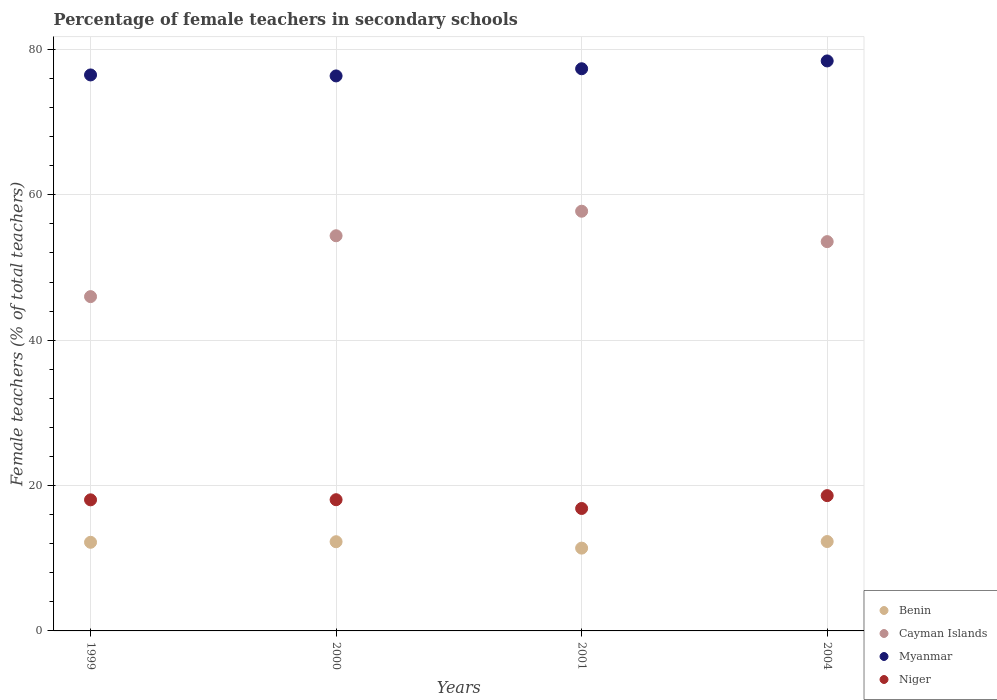How many different coloured dotlines are there?
Ensure brevity in your answer.  4. What is the percentage of female teachers in Cayman Islands in 1999?
Make the answer very short. 45.99. Across all years, what is the maximum percentage of female teachers in Benin?
Give a very brief answer. 12.3. Across all years, what is the minimum percentage of female teachers in Cayman Islands?
Provide a succinct answer. 45.99. In which year was the percentage of female teachers in Cayman Islands maximum?
Your answer should be compact. 2001. What is the total percentage of female teachers in Niger in the graph?
Offer a terse response. 71.54. What is the difference between the percentage of female teachers in Myanmar in 1999 and that in 2001?
Give a very brief answer. -0.85. What is the difference between the percentage of female teachers in Cayman Islands in 2001 and the percentage of female teachers in Niger in 2000?
Your answer should be compact. 39.69. What is the average percentage of female teachers in Cayman Islands per year?
Offer a terse response. 52.91. In the year 2004, what is the difference between the percentage of female teachers in Niger and percentage of female teachers in Myanmar?
Provide a short and direct response. -59.8. In how many years, is the percentage of female teachers in Benin greater than 24 %?
Make the answer very short. 0. What is the ratio of the percentage of female teachers in Cayman Islands in 1999 to that in 2000?
Keep it short and to the point. 0.85. Is the difference between the percentage of female teachers in Niger in 1999 and 2001 greater than the difference between the percentage of female teachers in Myanmar in 1999 and 2001?
Your answer should be compact. Yes. What is the difference between the highest and the second highest percentage of female teachers in Cayman Islands?
Give a very brief answer. 3.38. What is the difference between the highest and the lowest percentage of female teachers in Myanmar?
Provide a short and direct response. 2.06. In how many years, is the percentage of female teachers in Myanmar greater than the average percentage of female teachers in Myanmar taken over all years?
Offer a terse response. 2. Is it the case that in every year, the sum of the percentage of female teachers in Myanmar and percentage of female teachers in Benin  is greater than the sum of percentage of female teachers in Niger and percentage of female teachers in Cayman Islands?
Ensure brevity in your answer.  No. How many dotlines are there?
Ensure brevity in your answer.  4. How many years are there in the graph?
Ensure brevity in your answer.  4. Does the graph contain any zero values?
Your response must be concise. No. Does the graph contain grids?
Your answer should be compact. Yes. Where does the legend appear in the graph?
Your answer should be very brief. Bottom right. What is the title of the graph?
Your response must be concise. Percentage of female teachers in secondary schools. What is the label or title of the Y-axis?
Your response must be concise. Female teachers (% of total teachers). What is the Female teachers (% of total teachers) of Benin in 1999?
Provide a succinct answer. 12.19. What is the Female teachers (% of total teachers) in Cayman Islands in 1999?
Offer a very short reply. 45.99. What is the Female teachers (% of total teachers) of Myanmar in 1999?
Give a very brief answer. 76.49. What is the Female teachers (% of total teachers) in Niger in 1999?
Make the answer very short. 18.03. What is the Female teachers (% of total teachers) of Benin in 2000?
Make the answer very short. 12.27. What is the Female teachers (% of total teachers) in Cayman Islands in 2000?
Make the answer very short. 54.37. What is the Female teachers (% of total teachers) in Myanmar in 2000?
Ensure brevity in your answer.  76.35. What is the Female teachers (% of total teachers) of Niger in 2000?
Provide a short and direct response. 18.05. What is the Female teachers (% of total teachers) of Benin in 2001?
Ensure brevity in your answer.  11.39. What is the Female teachers (% of total teachers) of Cayman Islands in 2001?
Ensure brevity in your answer.  57.74. What is the Female teachers (% of total teachers) in Myanmar in 2001?
Your response must be concise. 77.34. What is the Female teachers (% of total teachers) in Niger in 2001?
Ensure brevity in your answer.  16.84. What is the Female teachers (% of total teachers) in Benin in 2004?
Your answer should be compact. 12.3. What is the Female teachers (% of total teachers) of Cayman Islands in 2004?
Provide a succinct answer. 53.56. What is the Female teachers (% of total teachers) in Myanmar in 2004?
Make the answer very short. 78.42. What is the Female teachers (% of total teachers) in Niger in 2004?
Keep it short and to the point. 18.61. Across all years, what is the maximum Female teachers (% of total teachers) of Benin?
Your response must be concise. 12.3. Across all years, what is the maximum Female teachers (% of total teachers) in Cayman Islands?
Provide a succinct answer. 57.74. Across all years, what is the maximum Female teachers (% of total teachers) of Myanmar?
Offer a very short reply. 78.42. Across all years, what is the maximum Female teachers (% of total teachers) of Niger?
Your answer should be very brief. 18.61. Across all years, what is the minimum Female teachers (% of total teachers) in Benin?
Give a very brief answer. 11.39. Across all years, what is the minimum Female teachers (% of total teachers) of Cayman Islands?
Offer a terse response. 45.99. Across all years, what is the minimum Female teachers (% of total teachers) of Myanmar?
Provide a short and direct response. 76.35. Across all years, what is the minimum Female teachers (% of total teachers) of Niger?
Your answer should be compact. 16.84. What is the total Female teachers (% of total teachers) of Benin in the graph?
Ensure brevity in your answer.  48.15. What is the total Female teachers (% of total teachers) in Cayman Islands in the graph?
Your answer should be very brief. 211.65. What is the total Female teachers (% of total teachers) of Myanmar in the graph?
Offer a very short reply. 308.6. What is the total Female teachers (% of total teachers) in Niger in the graph?
Keep it short and to the point. 71.54. What is the difference between the Female teachers (% of total teachers) in Benin in 1999 and that in 2000?
Your answer should be compact. -0.08. What is the difference between the Female teachers (% of total teachers) of Cayman Islands in 1999 and that in 2000?
Give a very brief answer. -8.37. What is the difference between the Female teachers (% of total teachers) in Myanmar in 1999 and that in 2000?
Make the answer very short. 0.14. What is the difference between the Female teachers (% of total teachers) of Niger in 1999 and that in 2000?
Provide a short and direct response. -0.02. What is the difference between the Female teachers (% of total teachers) of Benin in 1999 and that in 2001?
Keep it short and to the point. 0.8. What is the difference between the Female teachers (% of total teachers) of Cayman Islands in 1999 and that in 2001?
Your response must be concise. -11.75. What is the difference between the Female teachers (% of total teachers) in Myanmar in 1999 and that in 2001?
Your response must be concise. -0.85. What is the difference between the Female teachers (% of total teachers) of Niger in 1999 and that in 2001?
Ensure brevity in your answer.  1.19. What is the difference between the Female teachers (% of total teachers) of Benin in 1999 and that in 2004?
Provide a short and direct response. -0.1. What is the difference between the Female teachers (% of total teachers) of Cayman Islands in 1999 and that in 2004?
Make the answer very short. -7.56. What is the difference between the Female teachers (% of total teachers) of Myanmar in 1999 and that in 2004?
Provide a succinct answer. -1.93. What is the difference between the Female teachers (% of total teachers) of Niger in 1999 and that in 2004?
Offer a terse response. -0.58. What is the difference between the Female teachers (% of total teachers) in Benin in 2000 and that in 2001?
Your answer should be very brief. 0.88. What is the difference between the Female teachers (% of total teachers) in Cayman Islands in 2000 and that in 2001?
Ensure brevity in your answer.  -3.38. What is the difference between the Female teachers (% of total teachers) in Myanmar in 2000 and that in 2001?
Your answer should be very brief. -0.99. What is the difference between the Female teachers (% of total teachers) of Niger in 2000 and that in 2001?
Keep it short and to the point. 1.21. What is the difference between the Female teachers (% of total teachers) in Benin in 2000 and that in 2004?
Your answer should be very brief. -0.03. What is the difference between the Female teachers (% of total teachers) of Cayman Islands in 2000 and that in 2004?
Provide a short and direct response. 0.81. What is the difference between the Female teachers (% of total teachers) of Myanmar in 2000 and that in 2004?
Provide a succinct answer. -2.06. What is the difference between the Female teachers (% of total teachers) in Niger in 2000 and that in 2004?
Make the answer very short. -0.56. What is the difference between the Female teachers (% of total teachers) of Benin in 2001 and that in 2004?
Give a very brief answer. -0.91. What is the difference between the Female teachers (% of total teachers) in Cayman Islands in 2001 and that in 2004?
Your response must be concise. 4.18. What is the difference between the Female teachers (% of total teachers) in Myanmar in 2001 and that in 2004?
Your response must be concise. -1.08. What is the difference between the Female teachers (% of total teachers) of Niger in 2001 and that in 2004?
Offer a terse response. -1.77. What is the difference between the Female teachers (% of total teachers) in Benin in 1999 and the Female teachers (% of total teachers) in Cayman Islands in 2000?
Your answer should be very brief. -42.17. What is the difference between the Female teachers (% of total teachers) of Benin in 1999 and the Female teachers (% of total teachers) of Myanmar in 2000?
Keep it short and to the point. -64.16. What is the difference between the Female teachers (% of total teachers) in Benin in 1999 and the Female teachers (% of total teachers) in Niger in 2000?
Your answer should be very brief. -5.86. What is the difference between the Female teachers (% of total teachers) of Cayman Islands in 1999 and the Female teachers (% of total teachers) of Myanmar in 2000?
Make the answer very short. -30.36. What is the difference between the Female teachers (% of total teachers) in Cayman Islands in 1999 and the Female teachers (% of total teachers) in Niger in 2000?
Make the answer very short. 27.94. What is the difference between the Female teachers (% of total teachers) in Myanmar in 1999 and the Female teachers (% of total teachers) in Niger in 2000?
Your answer should be very brief. 58.44. What is the difference between the Female teachers (% of total teachers) of Benin in 1999 and the Female teachers (% of total teachers) of Cayman Islands in 2001?
Offer a very short reply. -45.55. What is the difference between the Female teachers (% of total teachers) of Benin in 1999 and the Female teachers (% of total teachers) of Myanmar in 2001?
Provide a succinct answer. -65.15. What is the difference between the Female teachers (% of total teachers) of Benin in 1999 and the Female teachers (% of total teachers) of Niger in 2001?
Offer a very short reply. -4.65. What is the difference between the Female teachers (% of total teachers) of Cayman Islands in 1999 and the Female teachers (% of total teachers) of Myanmar in 2001?
Keep it short and to the point. -31.35. What is the difference between the Female teachers (% of total teachers) of Cayman Islands in 1999 and the Female teachers (% of total teachers) of Niger in 2001?
Keep it short and to the point. 29.15. What is the difference between the Female teachers (% of total teachers) of Myanmar in 1999 and the Female teachers (% of total teachers) of Niger in 2001?
Keep it short and to the point. 59.65. What is the difference between the Female teachers (% of total teachers) in Benin in 1999 and the Female teachers (% of total teachers) in Cayman Islands in 2004?
Make the answer very short. -41.36. What is the difference between the Female teachers (% of total teachers) of Benin in 1999 and the Female teachers (% of total teachers) of Myanmar in 2004?
Make the answer very short. -66.22. What is the difference between the Female teachers (% of total teachers) of Benin in 1999 and the Female teachers (% of total teachers) of Niger in 2004?
Make the answer very short. -6.42. What is the difference between the Female teachers (% of total teachers) of Cayman Islands in 1999 and the Female teachers (% of total teachers) of Myanmar in 2004?
Make the answer very short. -32.43. What is the difference between the Female teachers (% of total teachers) of Cayman Islands in 1999 and the Female teachers (% of total teachers) of Niger in 2004?
Make the answer very short. 27.38. What is the difference between the Female teachers (% of total teachers) in Myanmar in 1999 and the Female teachers (% of total teachers) in Niger in 2004?
Make the answer very short. 57.88. What is the difference between the Female teachers (% of total teachers) in Benin in 2000 and the Female teachers (% of total teachers) in Cayman Islands in 2001?
Provide a short and direct response. -45.47. What is the difference between the Female teachers (% of total teachers) of Benin in 2000 and the Female teachers (% of total teachers) of Myanmar in 2001?
Offer a terse response. -65.07. What is the difference between the Female teachers (% of total teachers) of Benin in 2000 and the Female teachers (% of total teachers) of Niger in 2001?
Give a very brief answer. -4.57. What is the difference between the Female teachers (% of total teachers) of Cayman Islands in 2000 and the Female teachers (% of total teachers) of Myanmar in 2001?
Ensure brevity in your answer.  -22.98. What is the difference between the Female teachers (% of total teachers) in Cayman Islands in 2000 and the Female teachers (% of total teachers) in Niger in 2001?
Your response must be concise. 37.52. What is the difference between the Female teachers (% of total teachers) of Myanmar in 2000 and the Female teachers (% of total teachers) of Niger in 2001?
Ensure brevity in your answer.  59.51. What is the difference between the Female teachers (% of total teachers) in Benin in 2000 and the Female teachers (% of total teachers) in Cayman Islands in 2004?
Offer a terse response. -41.28. What is the difference between the Female teachers (% of total teachers) in Benin in 2000 and the Female teachers (% of total teachers) in Myanmar in 2004?
Your answer should be compact. -66.14. What is the difference between the Female teachers (% of total teachers) of Benin in 2000 and the Female teachers (% of total teachers) of Niger in 2004?
Provide a succinct answer. -6.34. What is the difference between the Female teachers (% of total teachers) of Cayman Islands in 2000 and the Female teachers (% of total teachers) of Myanmar in 2004?
Your answer should be compact. -24.05. What is the difference between the Female teachers (% of total teachers) in Cayman Islands in 2000 and the Female teachers (% of total teachers) in Niger in 2004?
Keep it short and to the point. 35.75. What is the difference between the Female teachers (% of total teachers) in Myanmar in 2000 and the Female teachers (% of total teachers) in Niger in 2004?
Your answer should be very brief. 57.74. What is the difference between the Female teachers (% of total teachers) of Benin in 2001 and the Female teachers (% of total teachers) of Cayman Islands in 2004?
Give a very brief answer. -42.17. What is the difference between the Female teachers (% of total teachers) of Benin in 2001 and the Female teachers (% of total teachers) of Myanmar in 2004?
Give a very brief answer. -67.03. What is the difference between the Female teachers (% of total teachers) in Benin in 2001 and the Female teachers (% of total teachers) in Niger in 2004?
Make the answer very short. -7.22. What is the difference between the Female teachers (% of total teachers) in Cayman Islands in 2001 and the Female teachers (% of total teachers) in Myanmar in 2004?
Keep it short and to the point. -20.68. What is the difference between the Female teachers (% of total teachers) in Cayman Islands in 2001 and the Female teachers (% of total teachers) in Niger in 2004?
Your answer should be very brief. 39.13. What is the difference between the Female teachers (% of total teachers) in Myanmar in 2001 and the Female teachers (% of total teachers) in Niger in 2004?
Make the answer very short. 58.73. What is the average Female teachers (% of total teachers) in Benin per year?
Offer a terse response. 12.04. What is the average Female teachers (% of total teachers) in Cayman Islands per year?
Ensure brevity in your answer.  52.91. What is the average Female teachers (% of total teachers) of Myanmar per year?
Your response must be concise. 77.15. What is the average Female teachers (% of total teachers) in Niger per year?
Your answer should be compact. 17.89. In the year 1999, what is the difference between the Female teachers (% of total teachers) in Benin and Female teachers (% of total teachers) in Cayman Islands?
Your response must be concise. -33.8. In the year 1999, what is the difference between the Female teachers (% of total teachers) of Benin and Female teachers (% of total teachers) of Myanmar?
Provide a short and direct response. -64.3. In the year 1999, what is the difference between the Female teachers (% of total teachers) in Benin and Female teachers (% of total teachers) in Niger?
Your answer should be very brief. -5.84. In the year 1999, what is the difference between the Female teachers (% of total teachers) of Cayman Islands and Female teachers (% of total teachers) of Myanmar?
Give a very brief answer. -30.5. In the year 1999, what is the difference between the Female teachers (% of total teachers) in Cayman Islands and Female teachers (% of total teachers) in Niger?
Provide a short and direct response. 27.96. In the year 1999, what is the difference between the Female teachers (% of total teachers) of Myanmar and Female teachers (% of total teachers) of Niger?
Give a very brief answer. 58.46. In the year 2000, what is the difference between the Female teachers (% of total teachers) of Benin and Female teachers (% of total teachers) of Cayman Islands?
Your answer should be compact. -42.09. In the year 2000, what is the difference between the Female teachers (% of total teachers) of Benin and Female teachers (% of total teachers) of Myanmar?
Your answer should be compact. -64.08. In the year 2000, what is the difference between the Female teachers (% of total teachers) in Benin and Female teachers (% of total teachers) in Niger?
Offer a very short reply. -5.78. In the year 2000, what is the difference between the Female teachers (% of total teachers) of Cayman Islands and Female teachers (% of total teachers) of Myanmar?
Provide a short and direct response. -21.99. In the year 2000, what is the difference between the Female teachers (% of total teachers) of Cayman Islands and Female teachers (% of total teachers) of Niger?
Keep it short and to the point. 36.31. In the year 2000, what is the difference between the Female teachers (% of total teachers) of Myanmar and Female teachers (% of total teachers) of Niger?
Offer a very short reply. 58.3. In the year 2001, what is the difference between the Female teachers (% of total teachers) of Benin and Female teachers (% of total teachers) of Cayman Islands?
Your answer should be very brief. -46.35. In the year 2001, what is the difference between the Female teachers (% of total teachers) in Benin and Female teachers (% of total teachers) in Myanmar?
Ensure brevity in your answer.  -65.95. In the year 2001, what is the difference between the Female teachers (% of total teachers) in Benin and Female teachers (% of total teachers) in Niger?
Provide a short and direct response. -5.45. In the year 2001, what is the difference between the Female teachers (% of total teachers) in Cayman Islands and Female teachers (% of total teachers) in Myanmar?
Provide a short and direct response. -19.6. In the year 2001, what is the difference between the Female teachers (% of total teachers) of Cayman Islands and Female teachers (% of total teachers) of Niger?
Your answer should be compact. 40.9. In the year 2001, what is the difference between the Female teachers (% of total teachers) of Myanmar and Female teachers (% of total teachers) of Niger?
Provide a short and direct response. 60.5. In the year 2004, what is the difference between the Female teachers (% of total teachers) of Benin and Female teachers (% of total teachers) of Cayman Islands?
Keep it short and to the point. -41.26. In the year 2004, what is the difference between the Female teachers (% of total teachers) in Benin and Female teachers (% of total teachers) in Myanmar?
Provide a short and direct response. -66.12. In the year 2004, what is the difference between the Female teachers (% of total teachers) of Benin and Female teachers (% of total teachers) of Niger?
Offer a very short reply. -6.32. In the year 2004, what is the difference between the Female teachers (% of total teachers) of Cayman Islands and Female teachers (% of total teachers) of Myanmar?
Ensure brevity in your answer.  -24.86. In the year 2004, what is the difference between the Female teachers (% of total teachers) of Cayman Islands and Female teachers (% of total teachers) of Niger?
Your answer should be very brief. 34.94. In the year 2004, what is the difference between the Female teachers (% of total teachers) in Myanmar and Female teachers (% of total teachers) in Niger?
Your answer should be very brief. 59.8. What is the ratio of the Female teachers (% of total teachers) in Benin in 1999 to that in 2000?
Your response must be concise. 0.99. What is the ratio of the Female teachers (% of total teachers) in Cayman Islands in 1999 to that in 2000?
Give a very brief answer. 0.85. What is the ratio of the Female teachers (% of total teachers) of Niger in 1999 to that in 2000?
Make the answer very short. 1. What is the ratio of the Female teachers (% of total teachers) of Benin in 1999 to that in 2001?
Your answer should be compact. 1.07. What is the ratio of the Female teachers (% of total teachers) of Cayman Islands in 1999 to that in 2001?
Give a very brief answer. 0.8. What is the ratio of the Female teachers (% of total teachers) in Myanmar in 1999 to that in 2001?
Keep it short and to the point. 0.99. What is the ratio of the Female teachers (% of total teachers) of Niger in 1999 to that in 2001?
Give a very brief answer. 1.07. What is the ratio of the Female teachers (% of total teachers) in Benin in 1999 to that in 2004?
Your response must be concise. 0.99. What is the ratio of the Female teachers (% of total teachers) in Cayman Islands in 1999 to that in 2004?
Ensure brevity in your answer.  0.86. What is the ratio of the Female teachers (% of total teachers) of Myanmar in 1999 to that in 2004?
Offer a terse response. 0.98. What is the ratio of the Female teachers (% of total teachers) of Niger in 1999 to that in 2004?
Your answer should be compact. 0.97. What is the ratio of the Female teachers (% of total teachers) in Benin in 2000 to that in 2001?
Your response must be concise. 1.08. What is the ratio of the Female teachers (% of total teachers) of Cayman Islands in 2000 to that in 2001?
Make the answer very short. 0.94. What is the ratio of the Female teachers (% of total teachers) in Myanmar in 2000 to that in 2001?
Ensure brevity in your answer.  0.99. What is the ratio of the Female teachers (% of total teachers) of Niger in 2000 to that in 2001?
Your answer should be very brief. 1.07. What is the ratio of the Female teachers (% of total teachers) in Benin in 2000 to that in 2004?
Keep it short and to the point. 1. What is the ratio of the Female teachers (% of total teachers) of Cayman Islands in 2000 to that in 2004?
Keep it short and to the point. 1.02. What is the ratio of the Female teachers (% of total teachers) of Myanmar in 2000 to that in 2004?
Your answer should be compact. 0.97. What is the ratio of the Female teachers (% of total teachers) of Niger in 2000 to that in 2004?
Provide a succinct answer. 0.97. What is the ratio of the Female teachers (% of total teachers) of Benin in 2001 to that in 2004?
Make the answer very short. 0.93. What is the ratio of the Female teachers (% of total teachers) of Cayman Islands in 2001 to that in 2004?
Give a very brief answer. 1.08. What is the ratio of the Female teachers (% of total teachers) of Myanmar in 2001 to that in 2004?
Make the answer very short. 0.99. What is the ratio of the Female teachers (% of total teachers) of Niger in 2001 to that in 2004?
Your answer should be compact. 0.91. What is the difference between the highest and the second highest Female teachers (% of total teachers) of Benin?
Provide a short and direct response. 0.03. What is the difference between the highest and the second highest Female teachers (% of total teachers) of Cayman Islands?
Give a very brief answer. 3.38. What is the difference between the highest and the second highest Female teachers (% of total teachers) of Myanmar?
Your answer should be compact. 1.08. What is the difference between the highest and the second highest Female teachers (% of total teachers) in Niger?
Give a very brief answer. 0.56. What is the difference between the highest and the lowest Female teachers (% of total teachers) of Benin?
Your answer should be very brief. 0.91. What is the difference between the highest and the lowest Female teachers (% of total teachers) of Cayman Islands?
Provide a succinct answer. 11.75. What is the difference between the highest and the lowest Female teachers (% of total teachers) in Myanmar?
Keep it short and to the point. 2.06. What is the difference between the highest and the lowest Female teachers (% of total teachers) of Niger?
Your answer should be compact. 1.77. 